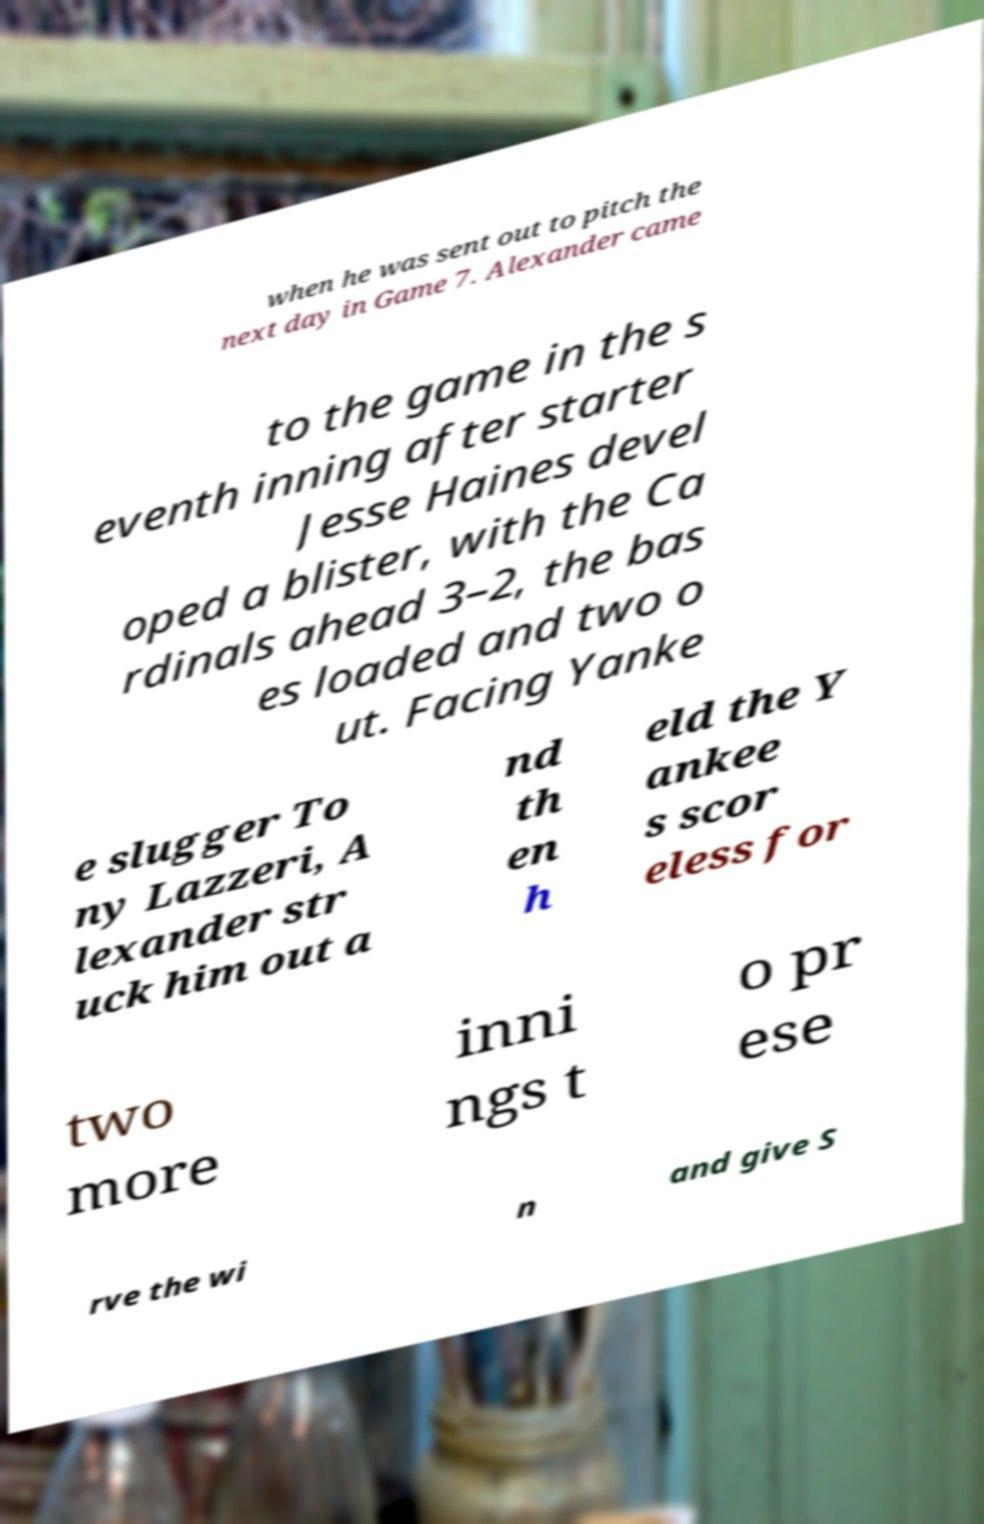Could you extract and type out the text from this image? when he was sent out to pitch the next day in Game 7. Alexander came to the game in the s eventh inning after starter Jesse Haines devel oped a blister, with the Ca rdinals ahead 3–2, the bas es loaded and two o ut. Facing Yanke e slugger To ny Lazzeri, A lexander str uck him out a nd th en h eld the Y ankee s scor eless for two more inni ngs t o pr ese rve the wi n and give S 